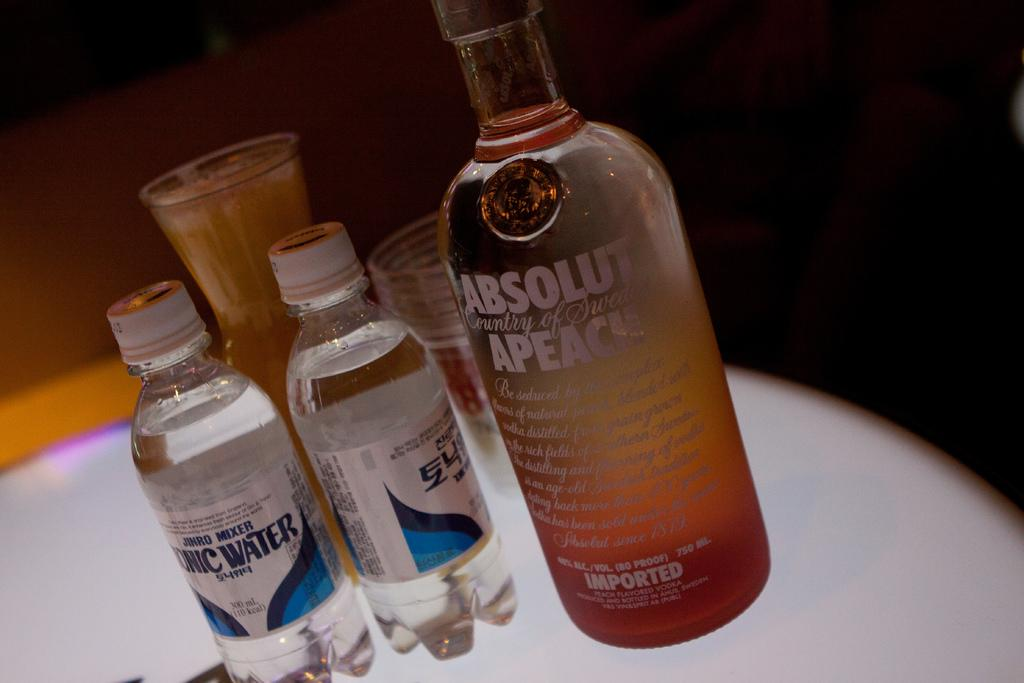What is present on the table in the image? There is a bottle and a glass on the table in the image. Can you describe the objects on the table? The objects on the table are a bottle and a glass. What type of alarm can be heard going off in the image? There is no alarm present in the image, as it only features a bottle and a glass on a table. 